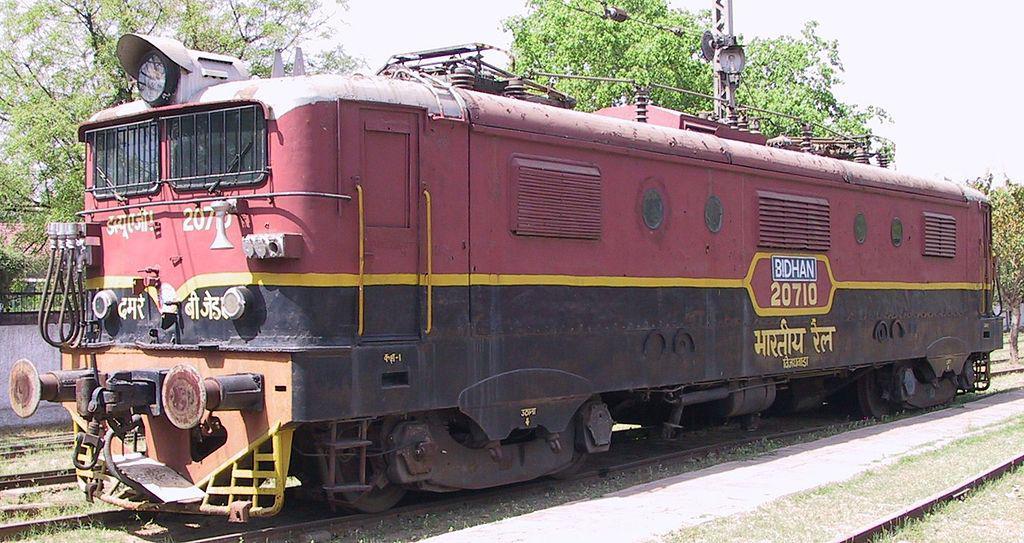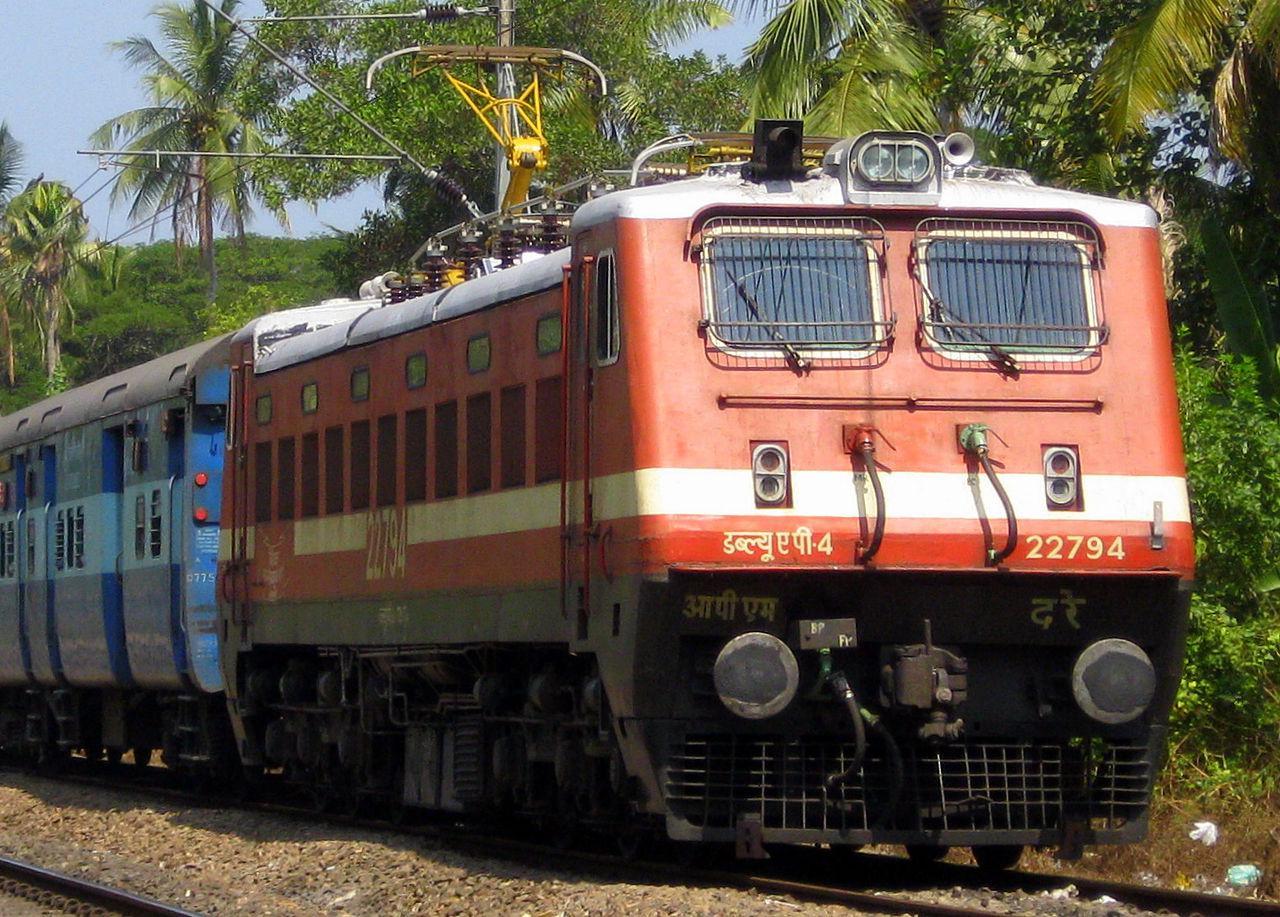The first image is the image on the left, the second image is the image on the right. Evaluate the accuracy of this statement regarding the images: "Two trains are heading toward the right.". Is it true? Answer yes or no. No. 